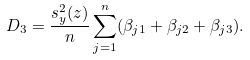Convert formula to latex. <formula><loc_0><loc_0><loc_500><loc_500>D _ { 3 } = \frac { s _ { y } ^ { 2 } ( z ) } n \sum _ { j = 1 } ^ { n } ( \beta _ { j 1 } + \beta _ { j 2 } + \beta _ { j 3 } ) .</formula> 